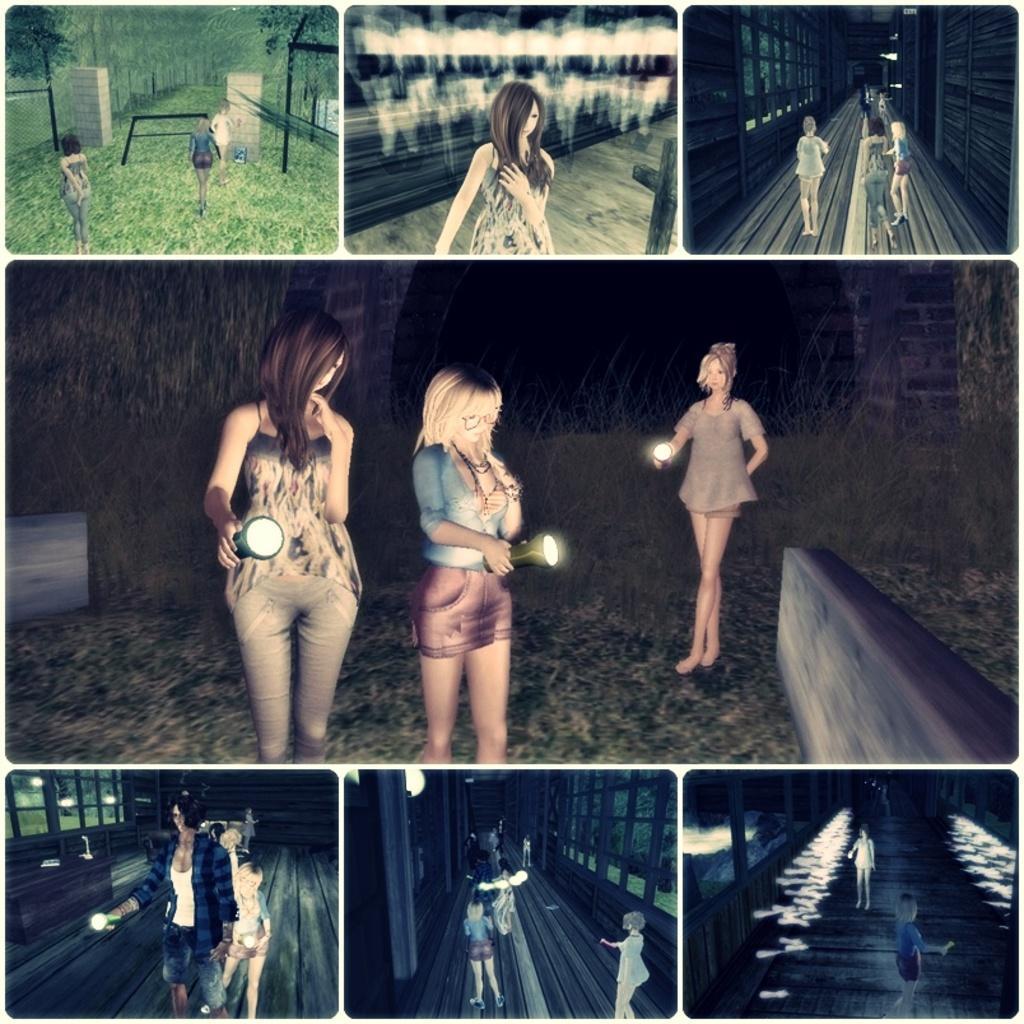In one or two sentences, can you explain what this image depicts? In the image we can see there is a collage of pictures. There are people standing on the ground and there are women holding torch in their hand. 